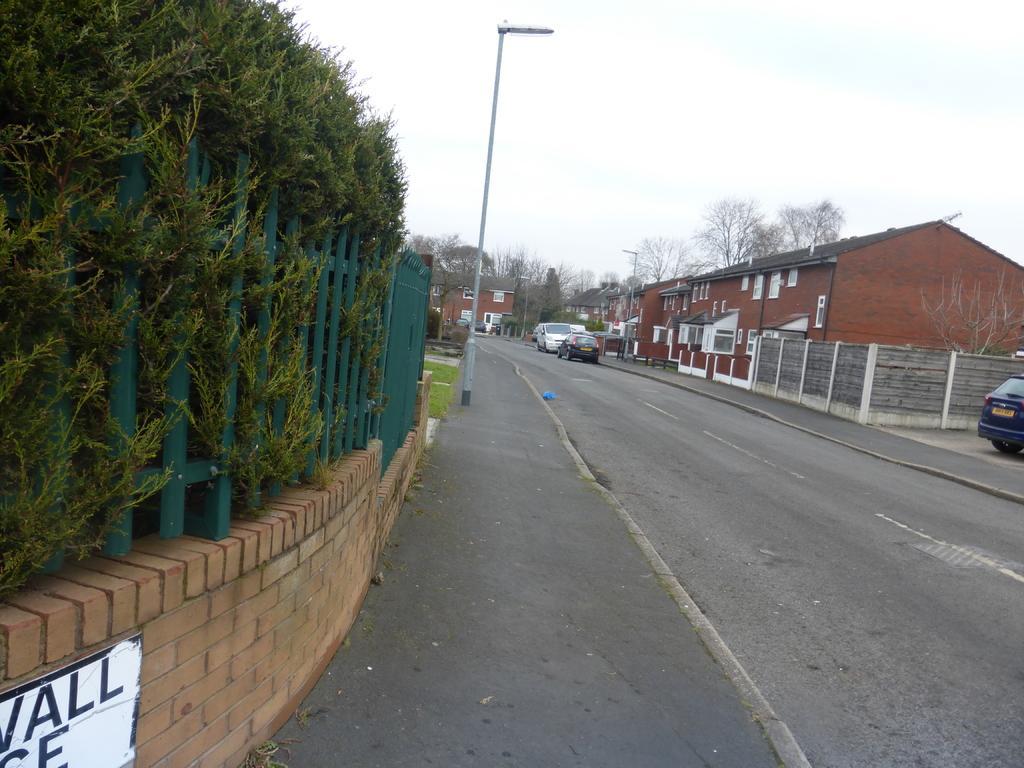How would you summarize this image in a sentence or two? This is an outside view. On the right side there is a road and I can see few vehicles on this road. On both sides of the road I can see the buildings, trees and poles. On the left side there is railing and also I can see few plants. At the top of the image I can see the sky. 